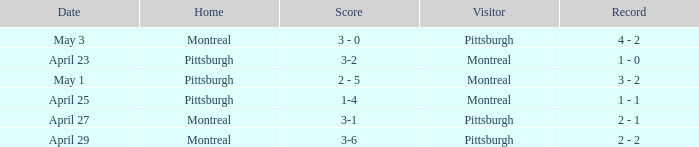Who visited on April 29? Pittsburgh. 